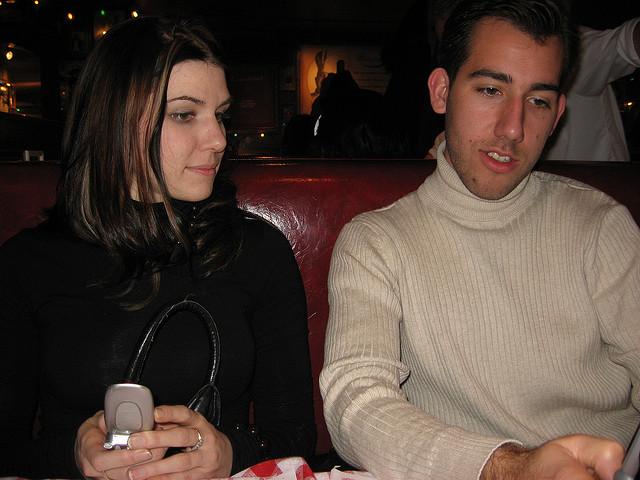Is this at night?
Keep it brief. Yes. What color is the guys' sweater?
Concise answer only. Cream. What do both of them have in their right hand?
Answer briefly. Phones. 